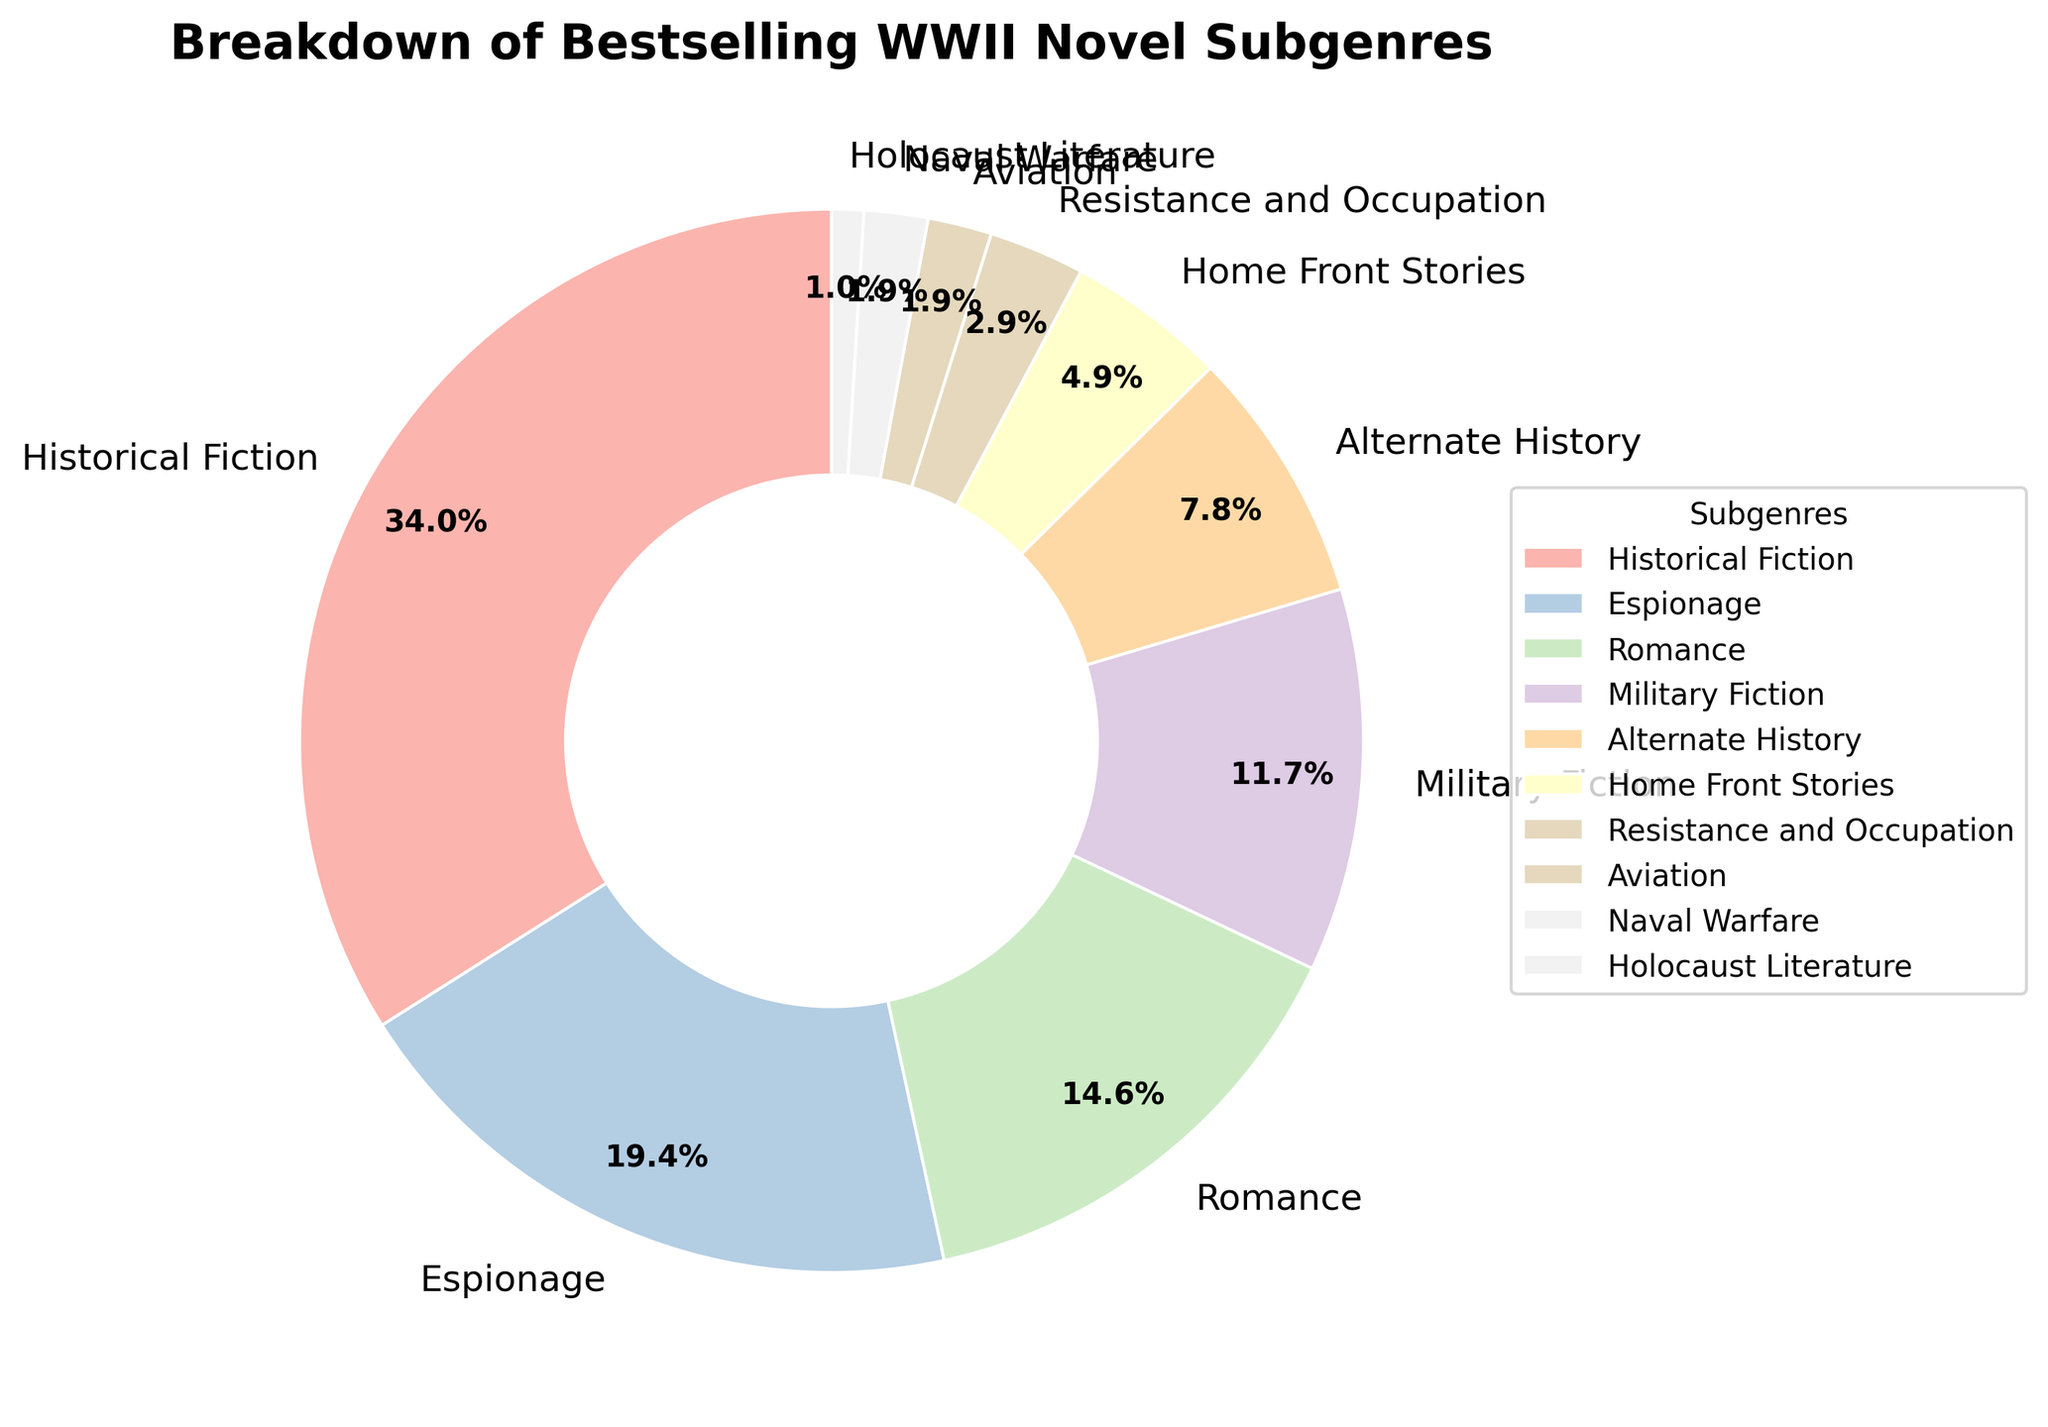What subgenre has the largest share of bestselling WWII novels? The largest slice of the pie chart represents the subgenre with the highest percentage. From the chart, Historical Fiction is the largest slice.
Answer: Historical Fiction Which two subgenres together make up more than 50% of the bestselling WWII novels? To determine this, identify the top two subgenres with the highest percentages and sum their values. Historical Fiction (35%) and Espionage (20%) together make 55%.
Answer: Historical Fiction and Espionage Which subgenres have the smallest percentage share, and what is that percentage? Look for the smallest slices in the pie chart and observe the labelled percentages. Holocaust Literature has the smallest share.
Answer: Holocaust Literature, 1% What is the combined percentage of Romance and Military Fiction subgenres? Add the percentages of the Romance (15%) and Military Fiction (12%) slices.
Answer: 27% How does the Aviation subgenre compare to Naval Warfare in terms of percentage? Both slices are labeled with their percentages. Here, Aviation and Naval Warfare both have 2%.
Answer: Equal How many subgenres have a percentage share of less than 10% of the bestselling WWII novels? Count the slices that are less than 10%. These are Alternate History (8%), Home Front Stories (5%), Resistance and Occupation (3%), Aviation (2%), Naval Warfare (2%), and Holocaust Literature (1%).
Answer: 6 What percentage of bestselling WWII novels consist of Alternate History, Home Front Stories, and Resistance and Occupation combined? Sum the percentages of Alternate History (8%), Home Front Stories (5%), and Resistance and Occupation (3%).
Answer: 16% Which subgenre is represented by the pastel green color in the pie chart? Identify the slice that is shaded in pastel green. This color represents Historical Fiction.
Answer: Historical Fiction What is the average percentage of the subgenres that are above 10%? Identify subgenres over 10%, which are: Historical Fiction (35%), Espionage (20%), Romance (15%), Military Fiction (12%). Calculating the average: (35 + 20 + 15 + 12) / 4 = 82 / 4 = 20.5%.
Answer: 20.5% Between Alternate History and Resistance and Occupation, which subgenre has a higher percentage share and by how much? Compare the slices directly, Alternate History (8%) and Resistance and Occupation (3%). Subtract the smaller percentage from the larger one: 8% - 3% = 5%.
Answer: Alternate History by 5% 